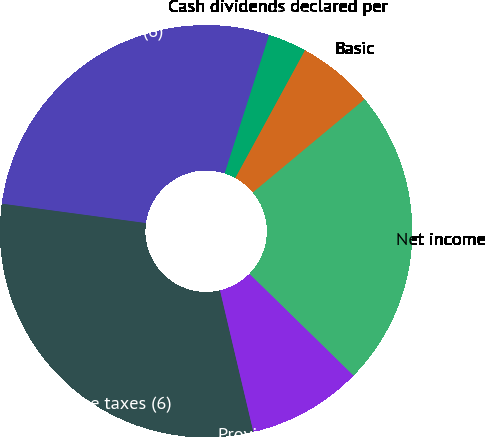<chart> <loc_0><loc_0><loc_500><loc_500><pie_chart><fcel>Operating income (6)<fcel>Income before income taxes (6)<fcel>Provision for income taxes<fcel>Net income<fcel>Basic<fcel>Diluted<fcel>Cash dividends declared per<nl><fcel>27.82%<fcel>30.82%<fcel>8.99%<fcel>23.39%<fcel>5.99%<fcel>3.0%<fcel>0.0%<nl></chart> 